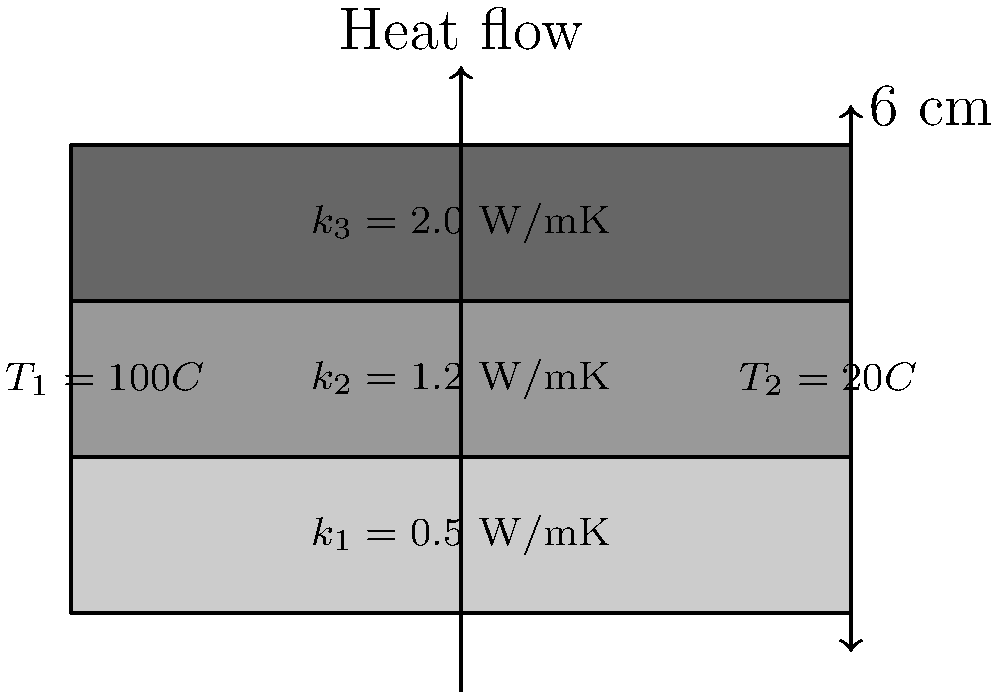Given a composite wall consisting of three layers with thermal conductivities $k_1 = 0.5$ W/mK, $k_2 = 1.2$ W/mK, and $k_3 = 2.0$ W/mK, each 2 cm thick, and surface temperatures of 100°C and 20°C, calculate the heat flux through the wall in W/m². Assume steady-state conditions and one-dimensional heat transfer. To solve this problem, we'll use the concept of thermal resistance in series and Fourier's law of heat conduction. Let's break it down step-by-step:

1) The total thermal resistance is the sum of individual layer resistances:
   $$R_{total} = R_1 + R_2 + R_3$$

2) For each layer, thermal resistance is given by:
   $$R = \frac{L}{kA}$$
   where $L$ is thickness, $k$ is thermal conductivity, and $A$ is area (1 m² in this case)

3) Calculate resistances:
   $$R_1 = \frac{0.02}{0.5 \times 1} = 0.04 \text{ m²K/W}$$
   $$R_2 = \frac{0.02}{1.2 \times 1} = 0.0167 \text{ m²K/W}$$
   $$R_3 = \frac{0.02}{2.0 \times 1} = 0.01 \text{ m²K/W}$$

4) Total resistance:
   $$R_{total} = 0.04 + 0.0167 + 0.01 = 0.0667 \text{ m²K/W}$$

5) The heat flux can be calculated using:
   $$q = \frac{\Delta T}{R_{total}}$$
   where $\Delta T$ is the temperature difference

6) Substituting values:
   $$q = \frac{100 - 20}{0.0667} = 1199.4 \text{ W/m²}$$

Therefore, the heat flux through the composite wall is approximately 1199.4 W/m².
Answer: 1199.4 W/m² 